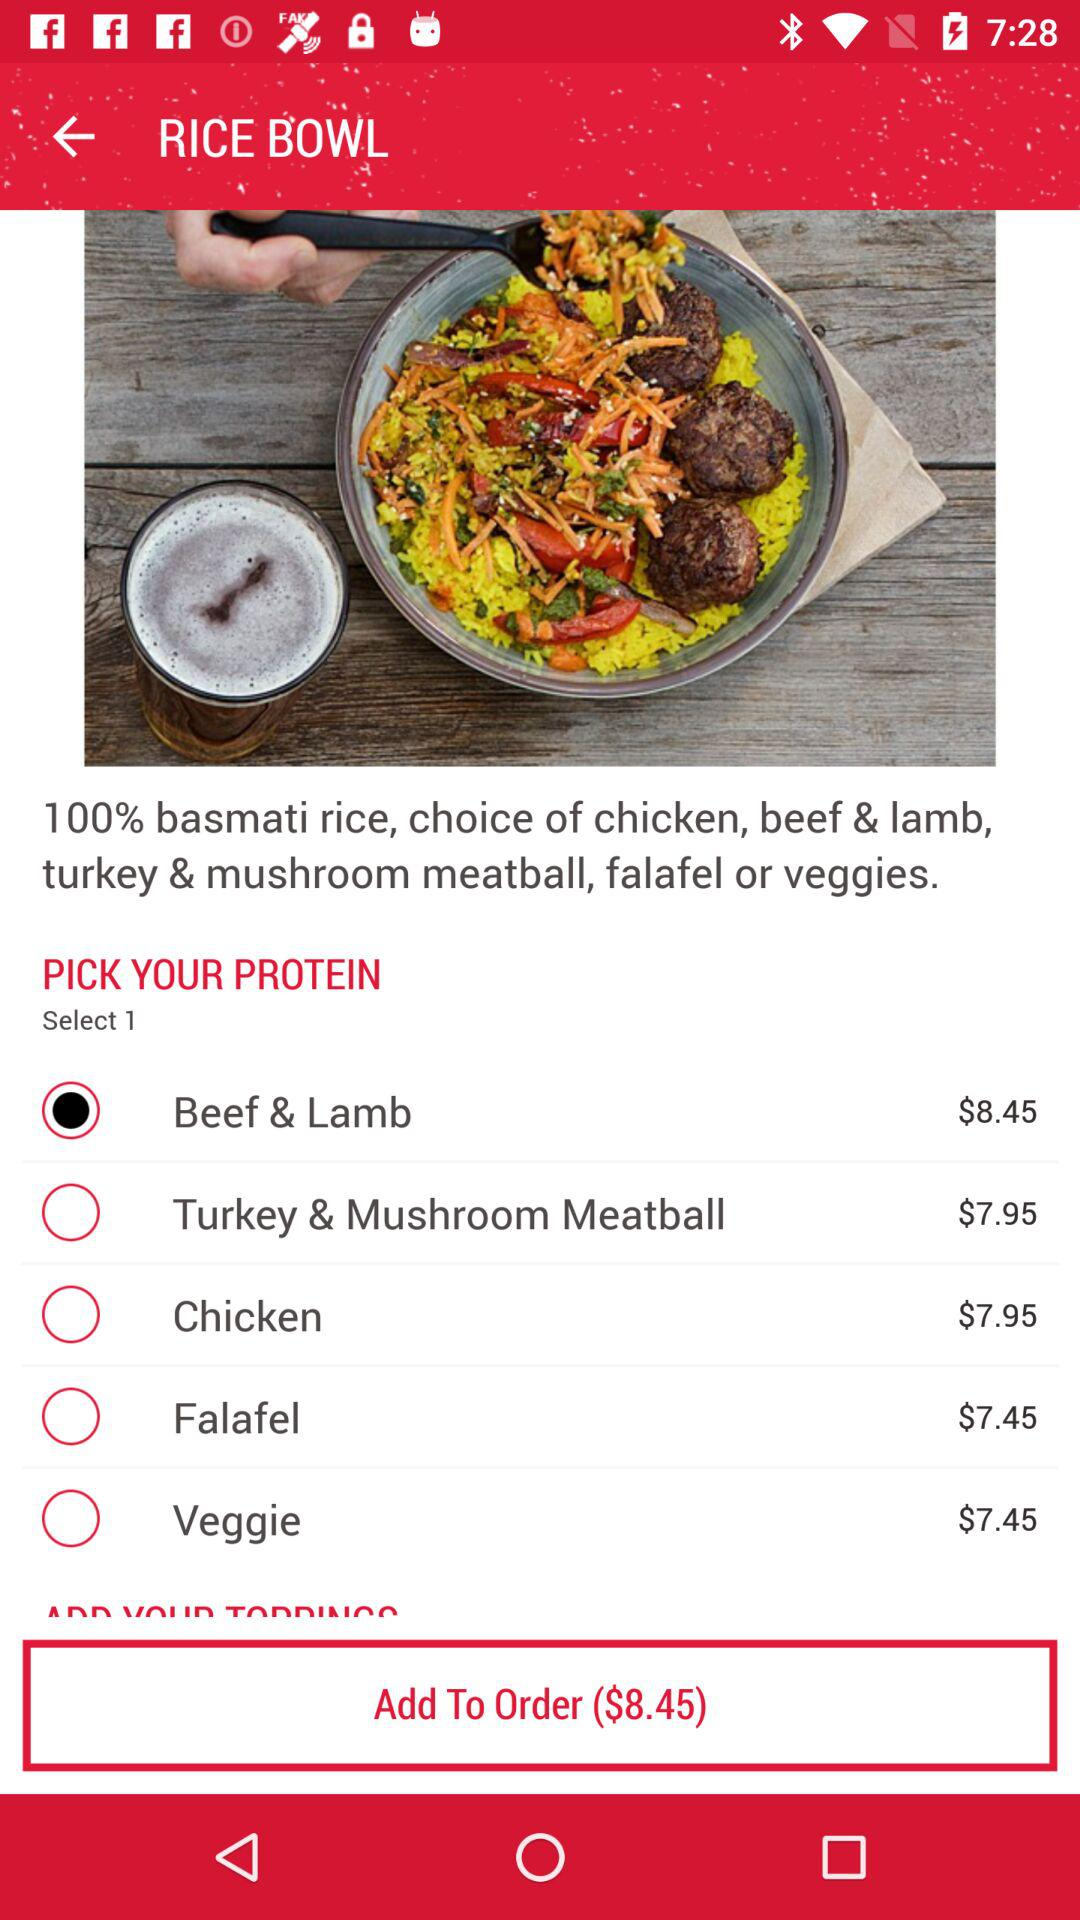How many proteins are available to choose from?
Answer the question using a single word or phrase. 5 